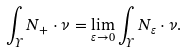<formula> <loc_0><loc_0><loc_500><loc_500>\int _ { \Upsilon } N _ { + } \cdot \nu = \lim _ { \varepsilon \rightarrow 0 } \int _ { \Upsilon } N _ { \varepsilon } \cdot \nu .</formula> 